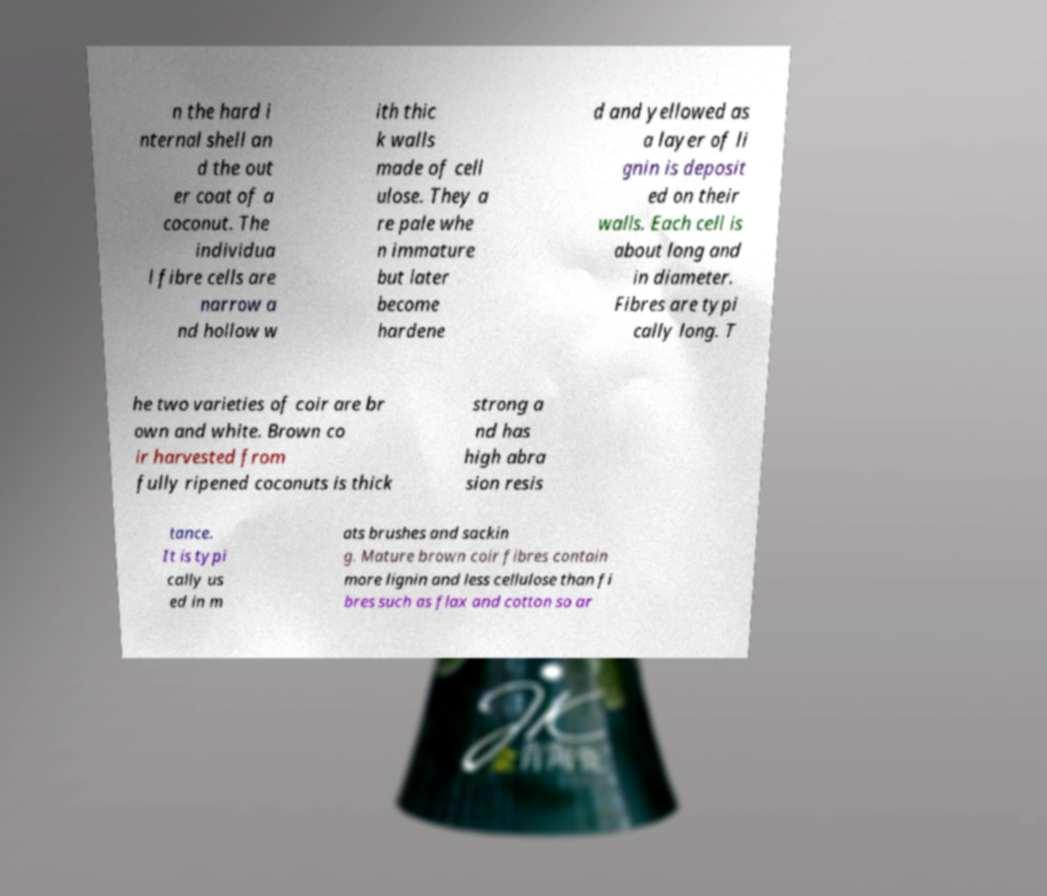Can you accurately transcribe the text from the provided image for me? n the hard i nternal shell an d the out er coat of a coconut. The individua l fibre cells are narrow a nd hollow w ith thic k walls made of cell ulose. They a re pale whe n immature but later become hardene d and yellowed as a layer of li gnin is deposit ed on their walls. Each cell is about long and in diameter. Fibres are typi cally long. T he two varieties of coir are br own and white. Brown co ir harvested from fully ripened coconuts is thick strong a nd has high abra sion resis tance. It is typi cally us ed in m ats brushes and sackin g. Mature brown coir fibres contain more lignin and less cellulose than fi bres such as flax and cotton so ar 